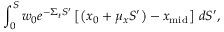<formula> <loc_0><loc_0><loc_500><loc_500>\int _ { 0 } ^ { S } w _ { 0 } e ^ { - \Sigma _ { t } S ^ { \prime } } \left [ \left ( x _ { 0 } + \mu _ { x } S ^ { \prime } \right ) - x _ { m i d } \right ] \, d S ^ { \prime } ,</formula> 